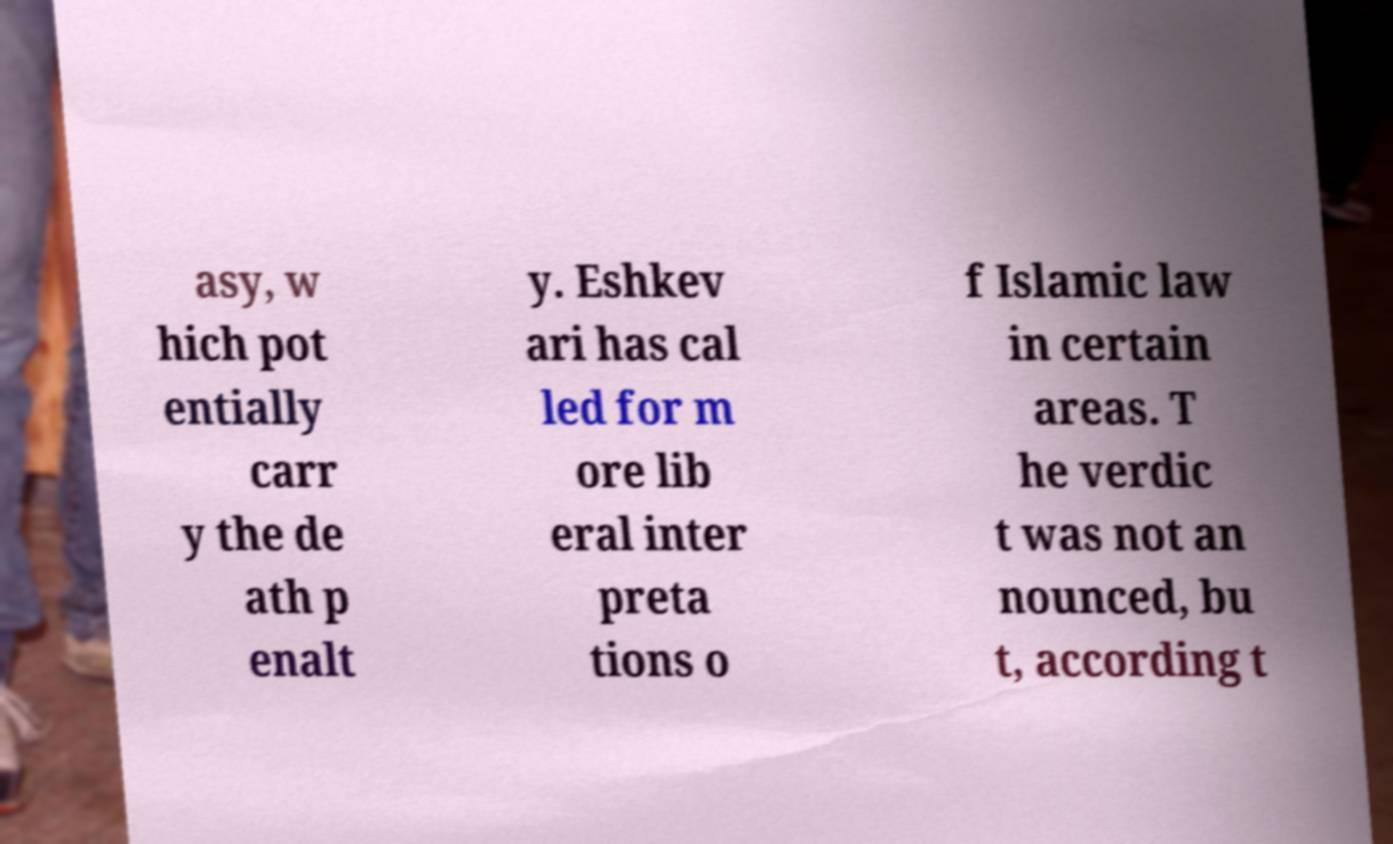Please identify and transcribe the text found in this image. asy, w hich pot entially carr y the de ath p enalt y. Eshkev ari has cal led for m ore lib eral inter preta tions o f Islamic law in certain areas. T he verdic t was not an nounced, bu t, according t 